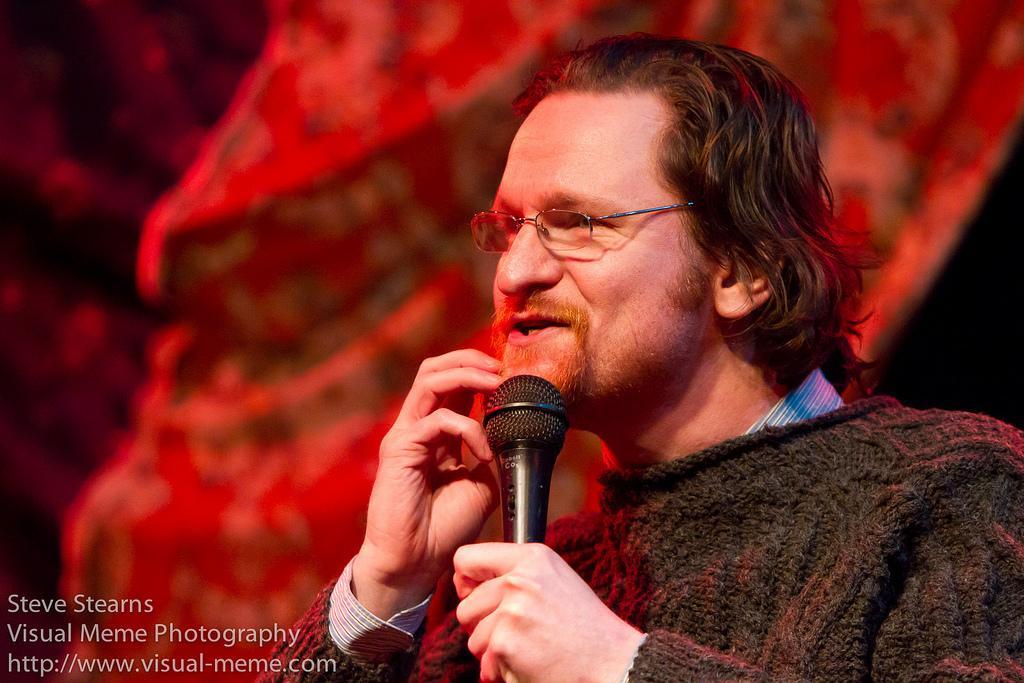Can you describe this image briefly? This man is highlighted in this picture. This man wore spectacles and holds mic. 